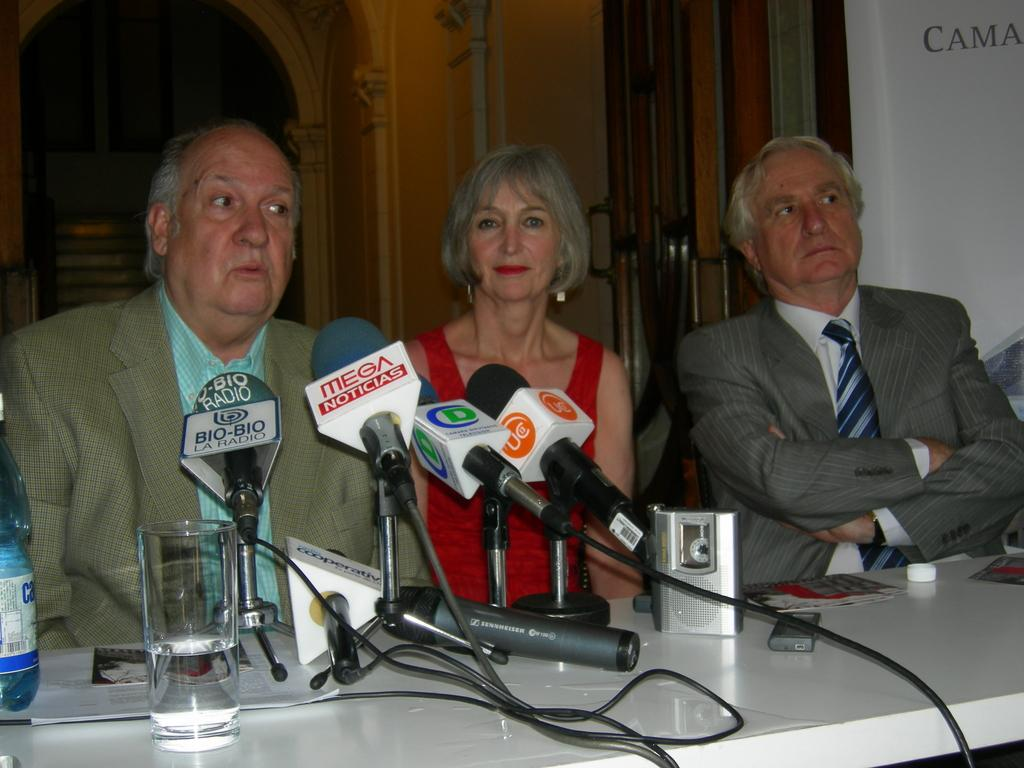How many people are sitting in the image? There are three persons sitting on chairs in the image. What is present on the table in the image? There is a microphone, a glass, a bottle, and papers on the table in the image. What can be seen in the background of the image? There is a wall and a door in the background of the image. What type of stretch can be seen on the fifth person in the image? There are only three persons present in the image, and no one is stretching. 